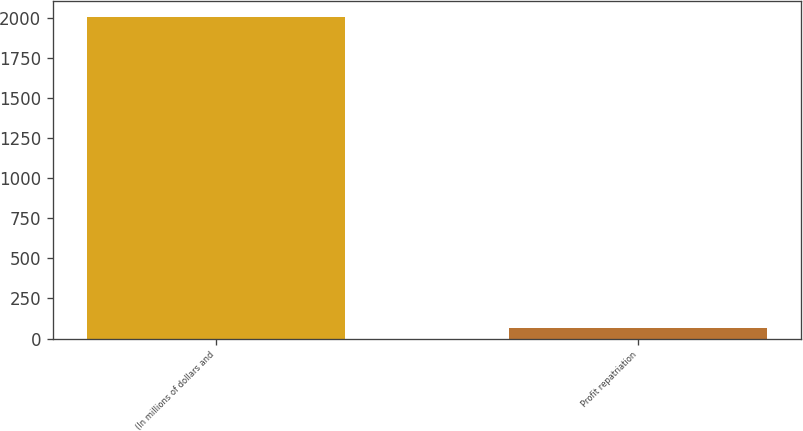<chart> <loc_0><loc_0><loc_500><loc_500><bar_chart><fcel>(In millions of dollars and<fcel>Profit repatriation<nl><fcel>2007<fcel>67.8<nl></chart> 